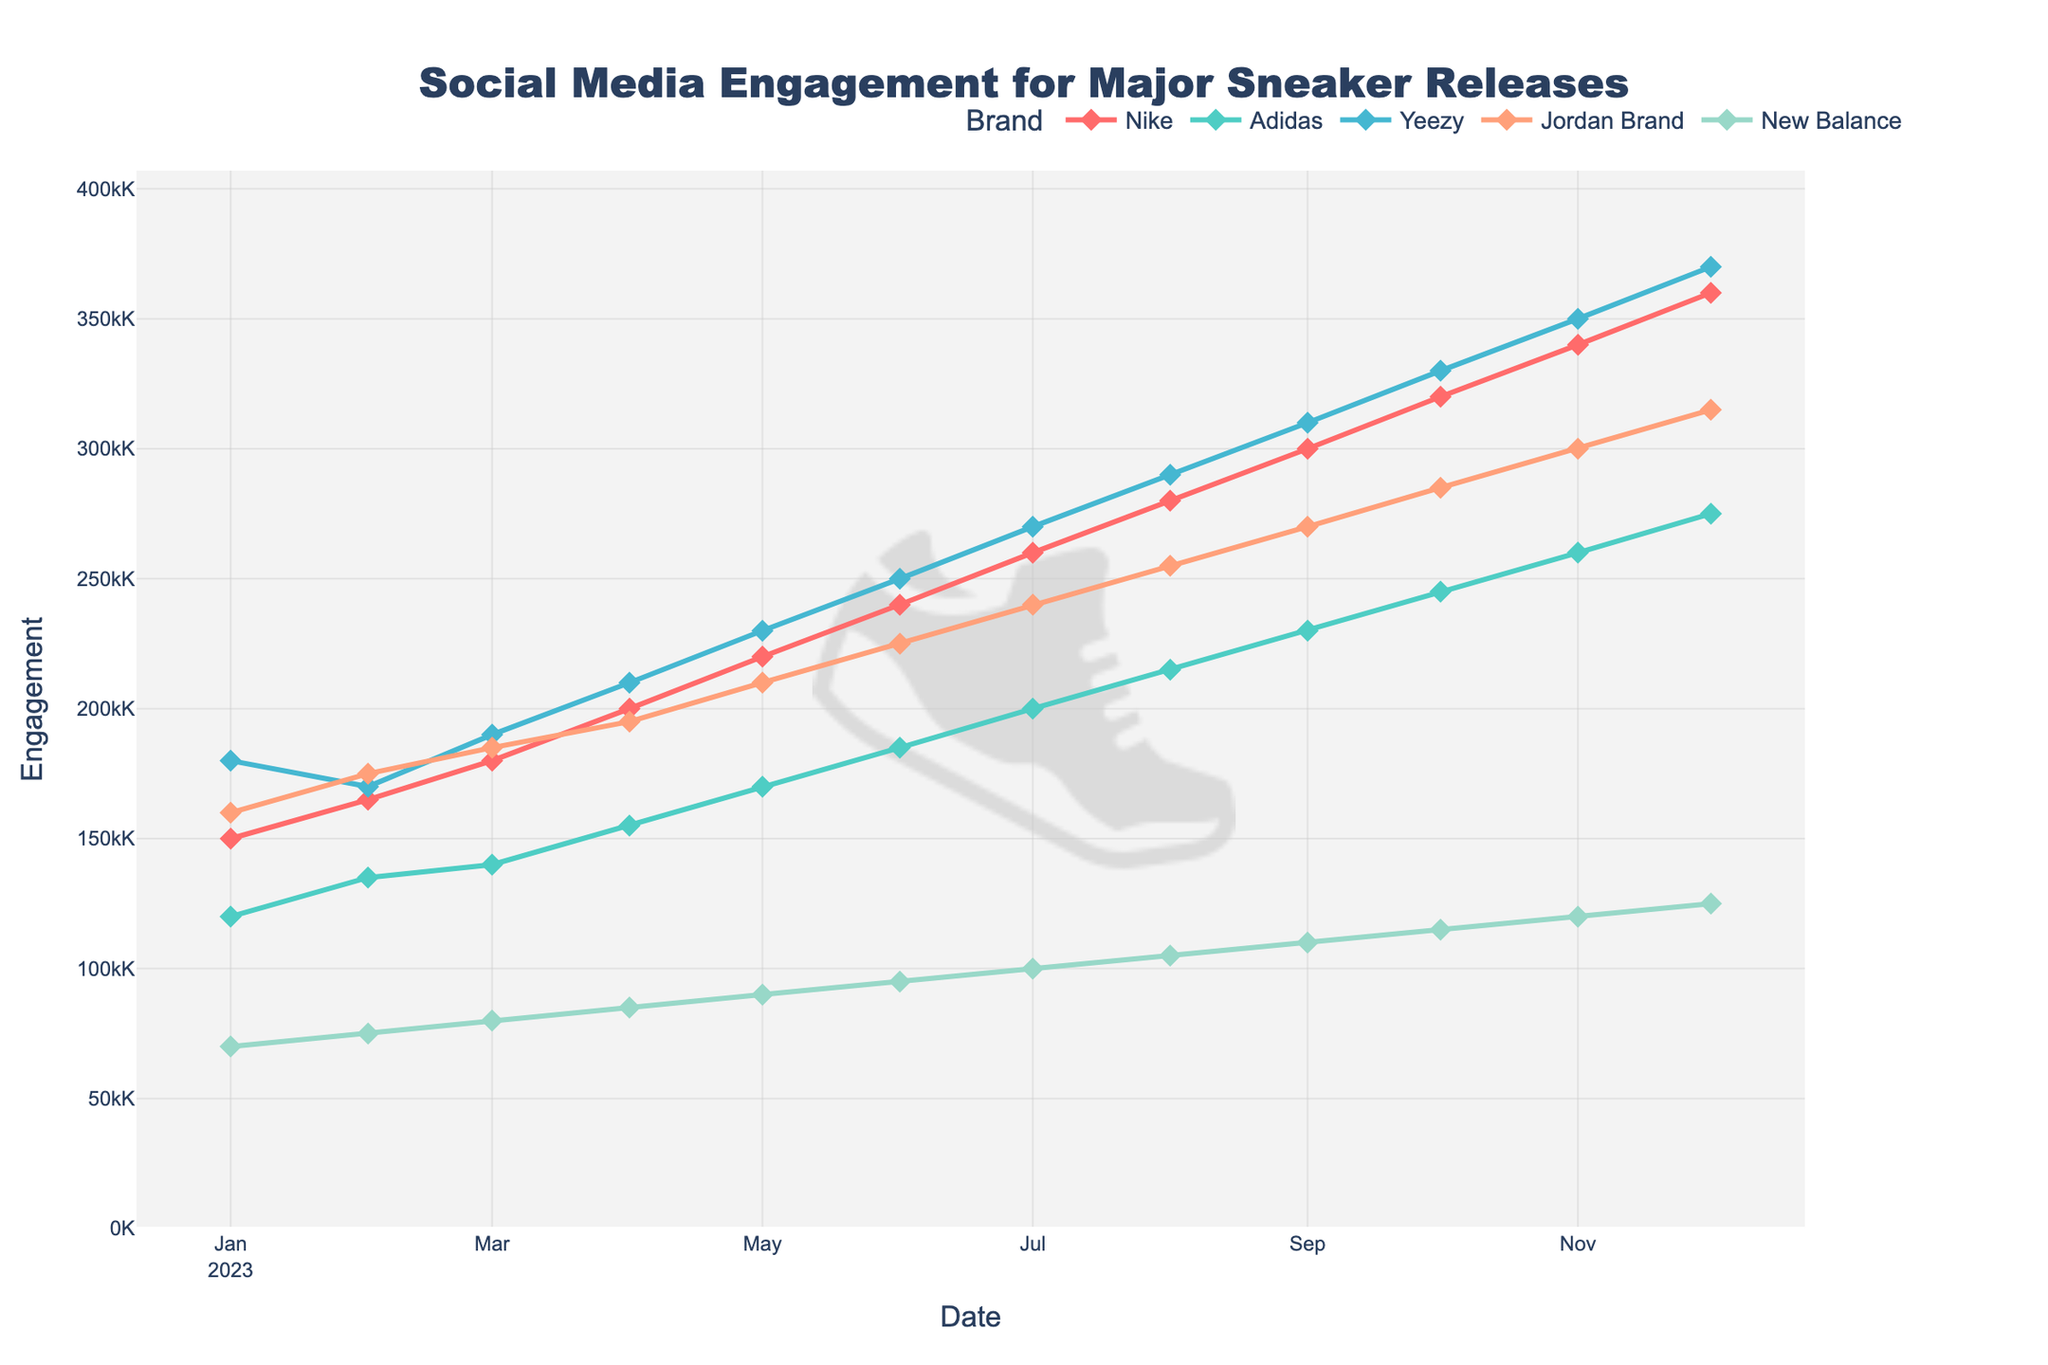When did Nike reach its highest social media engagement? Nike’s engagement peaks at the highest value towards the end of the chart, specifically in December 2023.
Answer: December 2023 Which brand had consistently increasing engagement every month? By looking at the trend lines, all brands (Nike, Adidas, Yeezy, Jordan Brand, and New Balance) show a consistent upward trend in engagement every month.
Answer: All brands In which month did Adidas surpass the 200,000 engagement mark? The data indicate that Adidas crossed the 200,000 engagement mark in July 2023.
Answer: July 2023 Compare the social media engagement of Yeezy and Jordan Brand in January 2023. Which one was higher and by how much? In January 2023, Yeezy had 180,000 engagements while Jordan Brand had 160,000. The difference is 20,000 in favor of Yeezy.
Answer: Yeezy by 20,000 What is the average social media engagement for New Balance in the second half of the year (July to December 2023)? The monthly engagements for New Balance from July to December are 100,000, 105,000, 110,000, 115,000, 120,000, and 125,000. The sum is 675,000 divided by 6 months, resulting in an average of 112,500.
Answer: 112,500 Which month showed the largest month-over-month increase for Nike? By comparing monthly increases, April 2023 shows the largest jump for Nike from 180,000 in March to 200,000, an increase of 20,000.
Answer: April 2023 How many times did Adidas and Jordan Brand's engagements intersect, and in which months? Examining the graph, Adidas and Jordan Brand's engagement lines intersect twice: around February 2023 and July 2023.
Answer: Twice, February and July What is the total social media engagement for all brands combined in December 2023? Summing the engagements in December 2023: Nike (360,000) + Adidas (275,000) + Yeezy (370,000) + Jordan Brand (315,000) + New Balance (125,000) = 1,445,000.
Answer: 1,445,000 Which brand had the steepest slope in engagement growth over the year? Yeezy consistently shows the steepest increase in engagement each month, indicated by the steepest curve on the graph.
Answer: Yeezy What is the engagement difference between Nike and New Balance in October 2023? In October 2023, Nike had 320,000 engagements and New Balance had 115,000. The difference is 320,000 - 115,000 = 205,000.
Answer: 205,000 